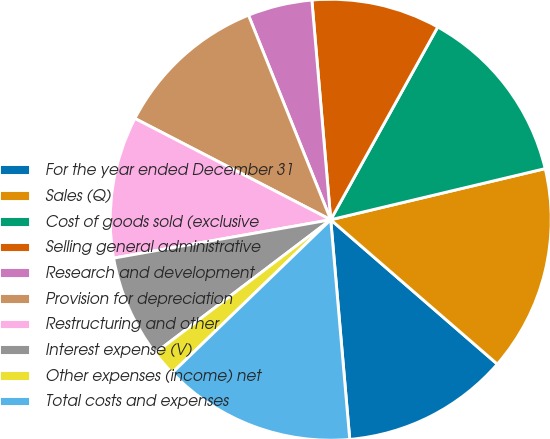<chart> <loc_0><loc_0><loc_500><loc_500><pie_chart><fcel>For the year ended December 31<fcel>Sales (Q)<fcel>Cost of goods sold (exclusive<fcel>Selling general administrative<fcel>Research and development<fcel>Provision for depreciation<fcel>Restructuring and other<fcel>Interest expense (V)<fcel>Other expenses (income) net<fcel>Total costs and expenses<nl><fcel>12.26%<fcel>15.09%<fcel>13.21%<fcel>9.43%<fcel>4.72%<fcel>11.32%<fcel>10.38%<fcel>7.55%<fcel>1.89%<fcel>14.15%<nl></chart> 